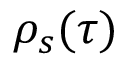Convert formula to latex. <formula><loc_0><loc_0><loc_500><loc_500>\rho _ { s } ( \tau )</formula> 